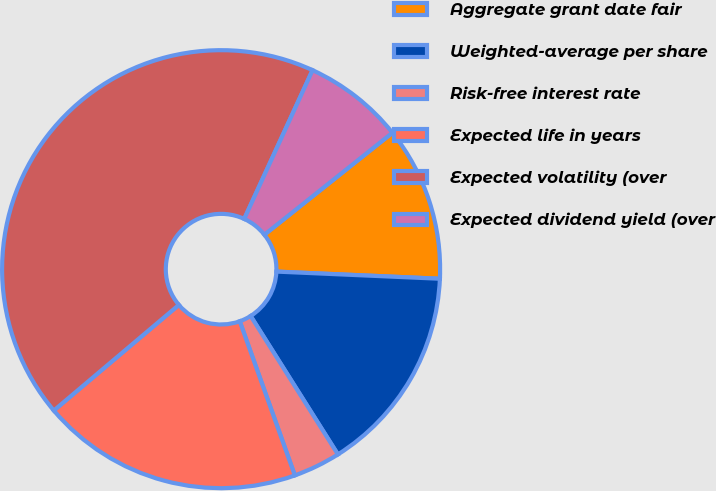Convert chart to OTSL. <chart><loc_0><loc_0><loc_500><loc_500><pie_chart><fcel>Aggregate grant date fair<fcel>Weighted-average per share<fcel>Risk-free interest rate<fcel>Expected life in years<fcel>Expected volatility (over<fcel>Expected dividend yield (over<nl><fcel>11.4%<fcel>15.35%<fcel>3.49%<fcel>19.3%<fcel>43.02%<fcel>7.44%<nl></chart> 